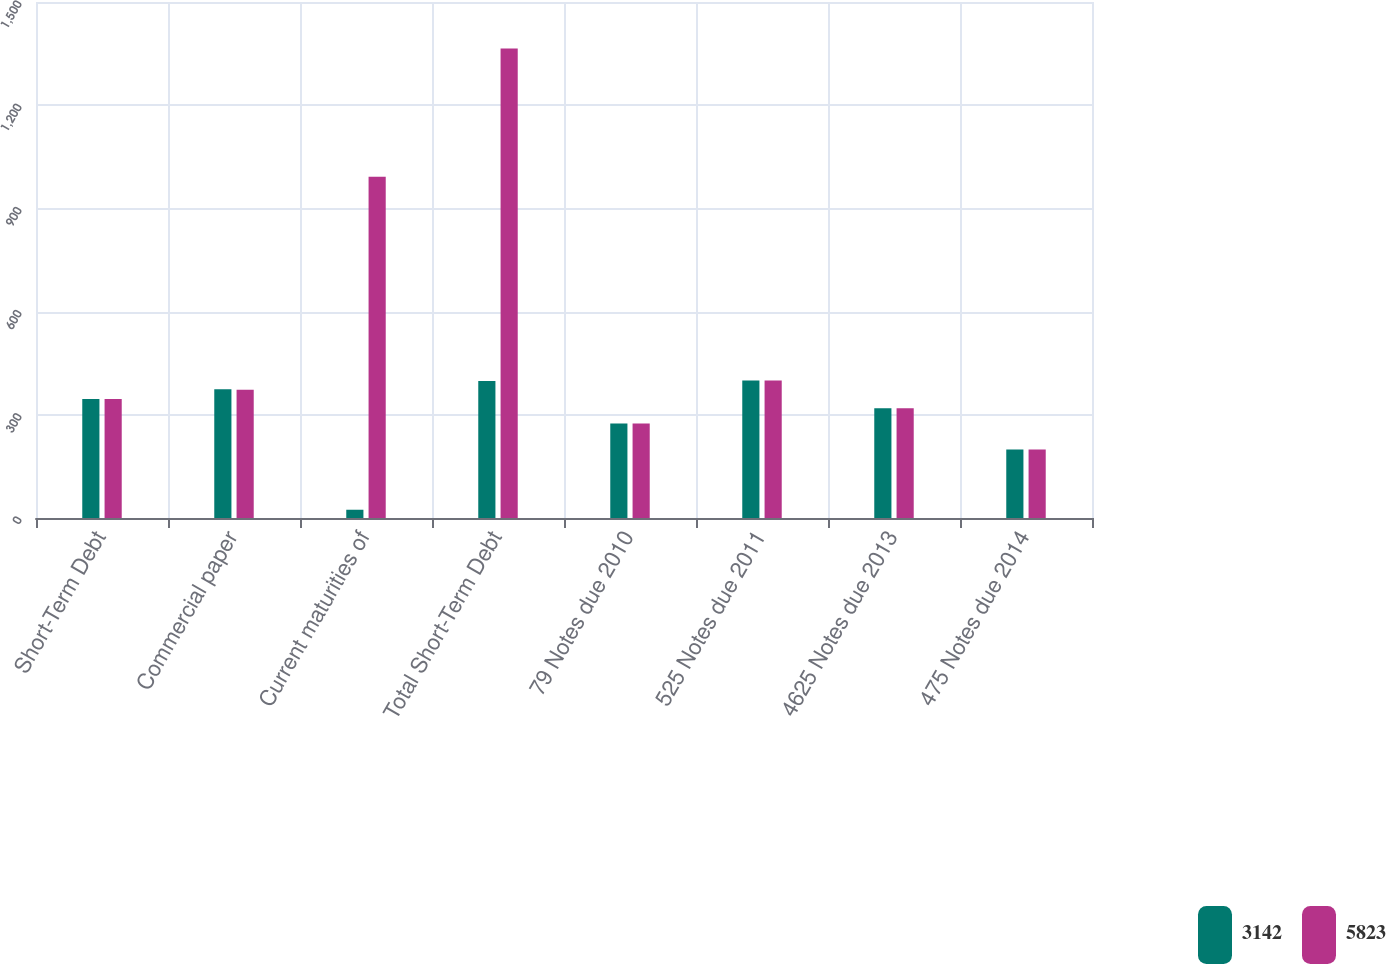Convert chart to OTSL. <chart><loc_0><loc_0><loc_500><loc_500><stacked_bar_chart><ecel><fcel>Short-Term Debt<fcel>Commercial paper<fcel>Current maturities of<fcel>Total Short-Term Debt<fcel>79 Notes due 2010<fcel>525 Notes due 2011<fcel>4625 Notes due 2013<fcel>475 Notes due 2014<nl><fcel>3142<fcel>346<fcel>374<fcel>24<fcel>398<fcel>275<fcel>400<fcel>319<fcel>199<nl><fcel>5823<fcel>346<fcel>373<fcel>992<fcel>1365<fcel>275<fcel>400<fcel>319<fcel>199<nl></chart> 